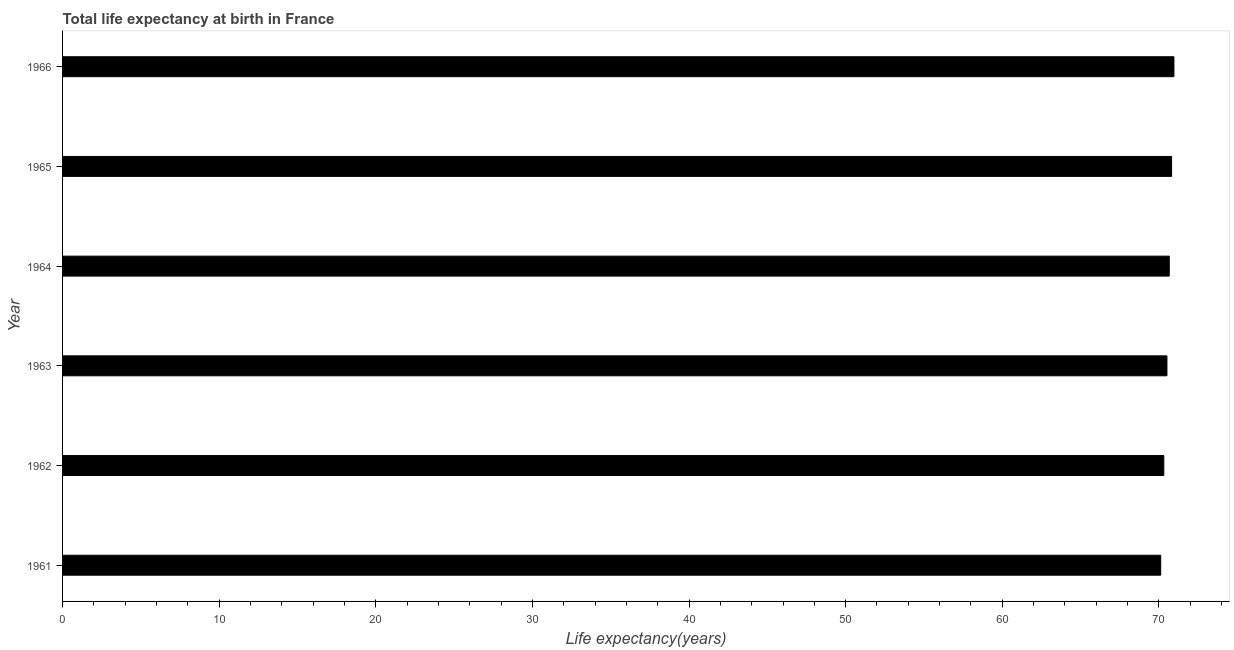Does the graph contain any zero values?
Your answer should be compact. No. What is the title of the graph?
Keep it short and to the point. Total life expectancy at birth in France. What is the label or title of the X-axis?
Ensure brevity in your answer.  Life expectancy(years). What is the label or title of the Y-axis?
Make the answer very short. Year. What is the life expectancy at birth in 1963?
Provide a succinct answer. 70.51. Across all years, what is the maximum life expectancy at birth?
Offer a very short reply. 70.96. Across all years, what is the minimum life expectancy at birth?
Keep it short and to the point. 70.12. In which year was the life expectancy at birth maximum?
Your answer should be compact. 1966. In which year was the life expectancy at birth minimum?
Provide a short and direct response. 1961. What is the sum of the life expectancy at birth?
Provide a succinct answer. 423.38. What is the difference between the life expectancy at birth in 1963 and 1964?
Keep it short and to the point. -0.15. What is the average life expectancy at birth per year?
Your response must be concise. 70.56. What is the median life expectancy at birth?
Make the answer very short. 70.59. What is the ratio of the life expectancy at birth in 1961 to that in 1966?
Provide a succinct answer. 0.99. Is the life expectancy at birth in 1963 less than that in 1964?
Keep it short and to the point. Yes. Is the difference between the life expectancy at birth in 1962 and 1965 greater than the difference between any two years?
Your answer should be very brief. No. What is the difference between the highest and the second highest life expectancy at birth?
Make the answer very short. 0.15. Is the sum of the life expectancy at birth in 1963 and 1966 greater than the maximum life expectancy at birth across all years?
Your answer should be compact. Yes. What is the difference between the highest and the lowest life expectancy at birth?
Give a very brief answer. 0.84. In how many years, is the life expectancy at birth greater than the average life expectancy at birth taken over all years?
Keep it short and to the point. 3. How many years are there in the graph?
Keep it short and to the point. 6. What is the Life expectancy(years) in 1961?
Ensure brevity in your answer.  70.12. What is the Life expectancy(years) of 1962?
Offer a very short reply. 70.31. What is the Life expectancy(years) of 1963?
Your answer should be very brief. 70.51. What is the Life expectancy(years) in 1964?
Make the answer very short. 70.66. What is the Life expectancy(years) of 1965?
Make the answer very short. 70.81. What is the Life expectancy(years) in 1966?
Make the answer very short. 70.96. What is the difference between the Life expectancy(years) in 1961 and 1962?
Provide a short and direct response. -0.2. What is the difference between the Life expectancy(years) in 1961 and 1963?
Your response must be concise. -0.4. What is the difference between the Life expectancy(years) in 1961 and 1964?
Your answer should be very brief. -0.55. What is the difference between the Life expectancy(years) in 1961 and 1965?
Keep it short and to the point. -0.7. What is the difference between the Life expectancy(years) in 1961 and 1966?
Give a very brief answer. -0.84. What is the difference between the Life expectancy(years) in 1962 and 1964?
Ensure brevity in your answer.  -0.35. What is the difference between the Life expectancy(years) in 1962 and 1965?
Give a very brief answer. -0.5. What is the difference between the Life expectancy(years) in 1962 and 1966?
Offer a very short reply. -0.65. What is the difference between the Life expectancy(years) in 1963 and 1964?
Your answer should be compact. -0.15. What is the difference between the Life expectancy(years) in 1963 and 1965?
Offer a terse response. -0.3. What is the difference between the Life expectancy(years) in 1963 and 1966?
Offer a very short reply. -0.45. What is the difference between the Life expectancy(years) in 1964 and 1965?
Your answer should be compact. -0.15. What is the difference between the Life expectancy(years) in 1964 and 1966?
Provide a succinct answer. -0.3. What is the difference between the Life expectancy(years) in 1965 and 1966?
Offer a terse response. -0.15. What is the ratio of the Life expectancy(years) in 1961 to that in 1965?
Offer a very short reply. 0.99. What is the ratio of the Life expectancy(years) in 1961 to that in 1966?
Ensure brevity in your answer.  0.99. What is the ratio of the Life expectancy(years) in 1962 to that in 1964?
Offer a very short reply. 0.99. What is the ratio of the Life expectancy(years) in 1962 to that in 1965?
Your answer should be very brief. 0.99. What is the ratio of the Life expectancy(years) in 1962 to that in 1966?
Provide a short and direct response. 0.99. What is the ratio of the Life expectancy(years) in 1963 to that in 1964?
Keep it short and to the point. 1. What is the ratio of the Life expectancy(years) in 1964 to that in 1966?
Offer a very short reply. 1. What is the ratio of the Life expectancy(years) in 1965 to that in 1966?
Ensure brevity in your answer.  1. 